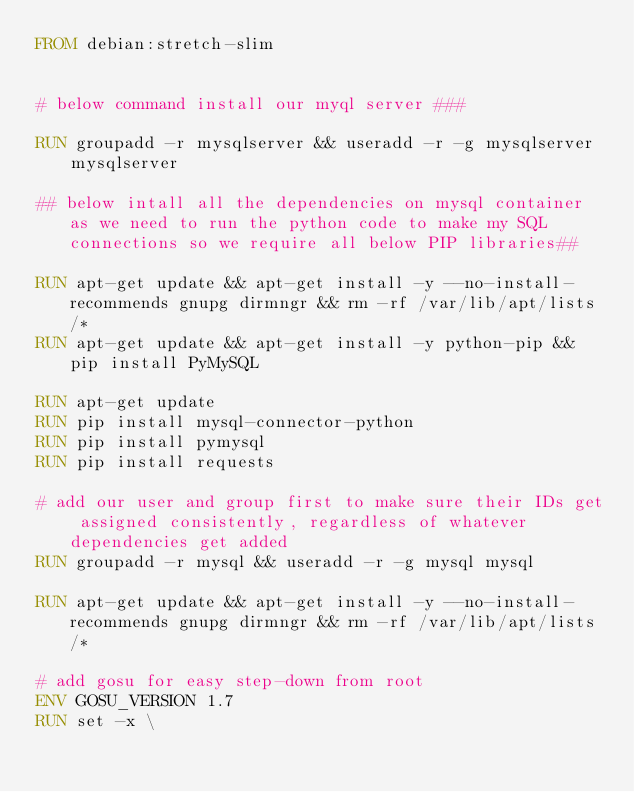Convert code to text. <code><loc_0><loc_0><loc_500><loc_500><_Dockerfile_>FROM debian:stretch-slim


# below command install our myql server ###

RUN groupadd -r mysqlserver && useradd -r -g mysqlserver mysqlserver

## below intall all the dependencies on mysql container as we need to run the python code to make my SQL connections so we require all below PIP libraries##

RUN apt-get update && apt-get install -y --no-install-recommends gnupg dirmngr && rm -rf /var/lib/apt/lists/*
RUN apt-get update && apt-get install -y python-pip && pip install PyMySQL

RUN apt-get update
RUN pip install mysql-connector-python
RUN pip install pymysql
RUN pip install requests

# add our user and group first to make sure their IDs get assigned consistently, regardless of whatever dependencies get added
RUN groupadd -r mysql && useradd -r -g mysql mysql

RUN apt-get update && apt-get install -y --no-install-recommends gnupg dirmngr && rm -rf /var/lib/apt/lists/*

# add gosu for easy step-down from root
ENV GOSU_VERSION 1.7
RUN set -x \</code> 